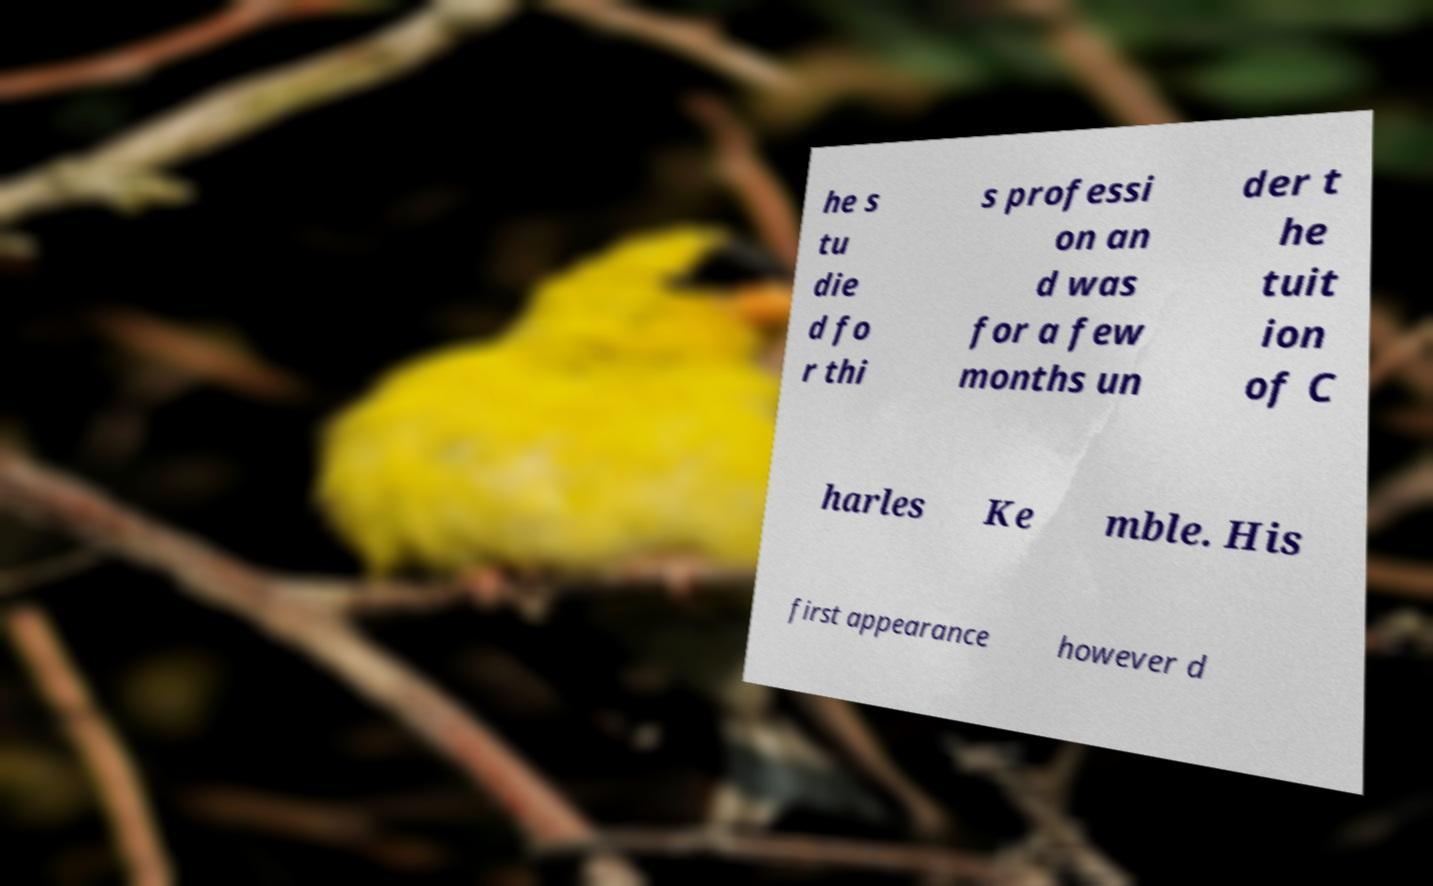Please identify and transcribe the text found in this image. he s tu die d fo r thi s professi on an d was for a few months un der t he tuit ion of C harles Ke mble. His first appearance however d 